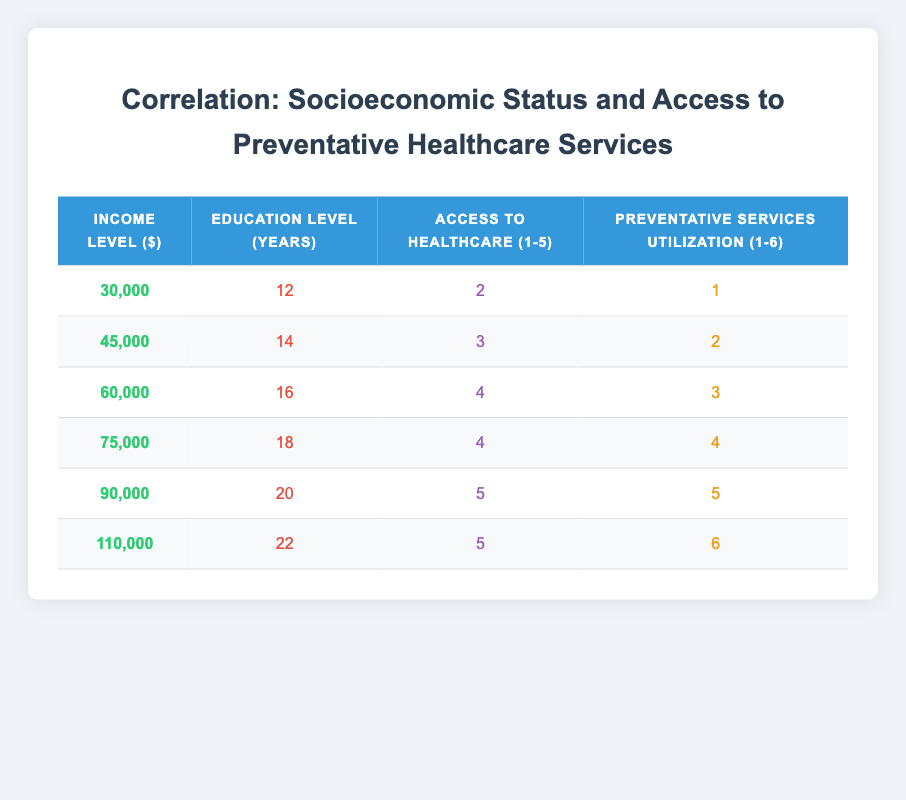What is the income level of the highest access to healthcare group? The highest access to healthcare is rated as 5, which is found in the last two rows for income levels of 90,000 and 110,000. Both have the same access rating, but 110,000 is the highest income among them.
Answer: 110,000 What is the educational level of the group with the lowest use of preventative services? The lowest use of preventative services is a rating of 1, which corresponds to the first row of the table where the educational level is 12 years.
Answer: 12 What is the average access to healthcare level for the groups with incomes greater than 60,000? The relevant groups are for incomes 75,000, 90,000, and 110,000 with access ratings of 4, 5, and 5 respectively. The average is calculated as (4 + 5 + 5) / 3 = 14 / 3 = approximately 4.67.
Answer: 4.67 Is the preventative services utilization increasing with higher income levels? By examining the table, it is noted that as the income levels increase, the utilization of preventative services also increases from 1 to 6, thus confirming the trend.
Answer: Yes What is the difference in access to healthcare between the lowest and highest income levels? The lowest income is at 30,000 with an access level of 2 and the highest income is 110,000 with an access level of 5. The difference is 5 - 2 = 3.
Answer: 3 